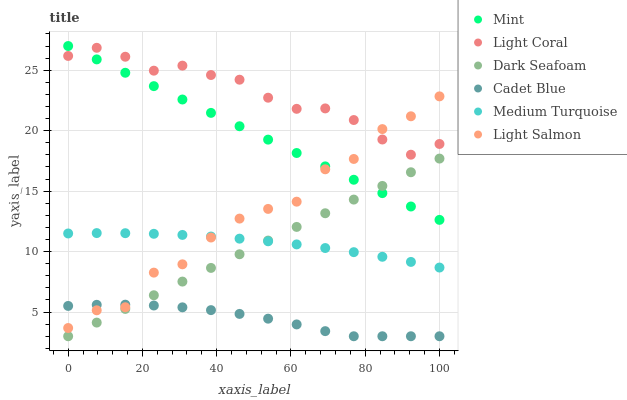Does Cadet Blue have the minimum area under the curve?
Answer yes or no. Yes. Does Light Coral have the maximum area under the curve?
Answer yes or no. Yes. Does Light Coral have the minimum area under the curve?
Answer yes or no. No. Does Cadet Blue have the maximum area under the curve?
Answer yes or no. No. Is Dark Seafoam the smoothest?
Answer yes or no. Yes. Is Light Salmon the roughest?
Answer yes or no. Yes. Is Cadet Blue the smoothest?
Answer yes or no. No. Is Cadet Blue the roughest?
Answer yes or no. No. Does Cadet Blue have the lowest value?
Answer yes or no. Yes. Does Light Coral have the lowest value?
Answer yes or no. No. Does Mint have the highest value?
Answer yes or no. Yes. Does Light Coral have the highest value?
Answer yes or no. No. Is Dark Seafoam less than Light Salmon?
Answer yes or no. Yes. Is Light Salmon greater than Dark Seafoam?
Answer yes or no. Yes. Does Light Coral intersect Light Salmon?
Answer yes or no. Yes. Is Light Coral less than Light Salmon?
Answer yes or no. No. Is Light Coral greater than Light Salmon?
Answer yes or no. No. Does Dark Seafoam intersect Light Salmon?
Answer yes or no. No. 